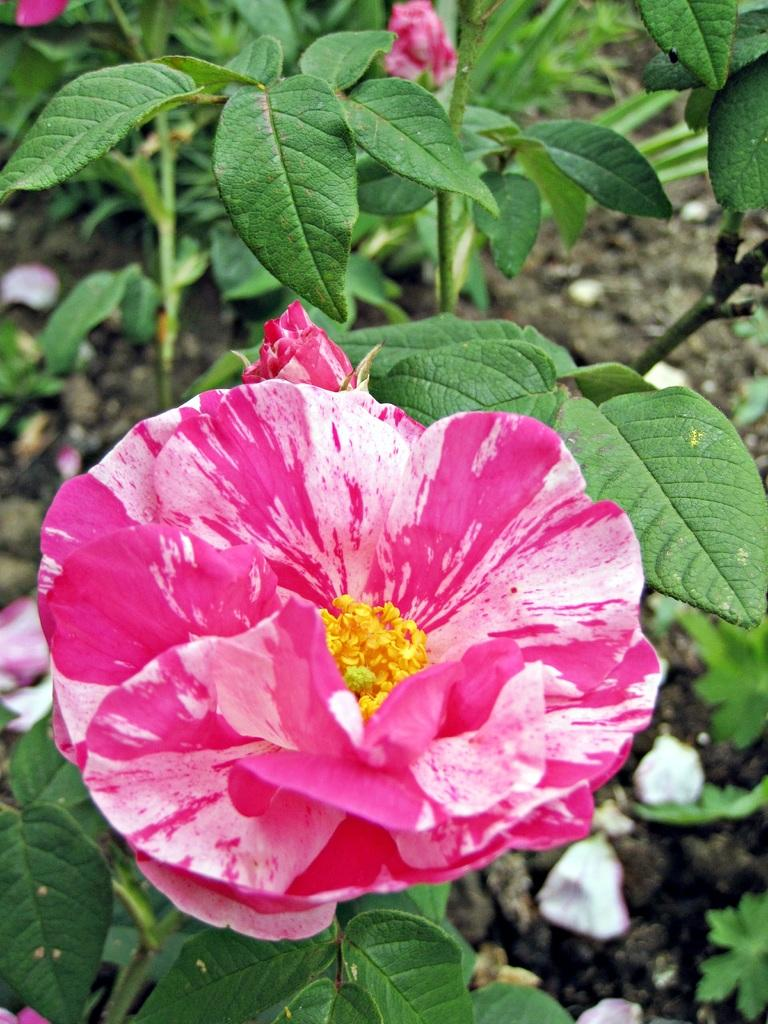What type of plant is visible in the image? There is a plant in the image. What is the plant's current stage of growth? The plant has a flower and buds, indicating that it is in a blooming stage. Are there any fallen petals visible in the image? Yes, flower petals are present on the soil in the image. What type of cloth is draped over the plant in the image? There is no cloth present in the image; it only features a plant with a flower, buds, and fallen petals. 